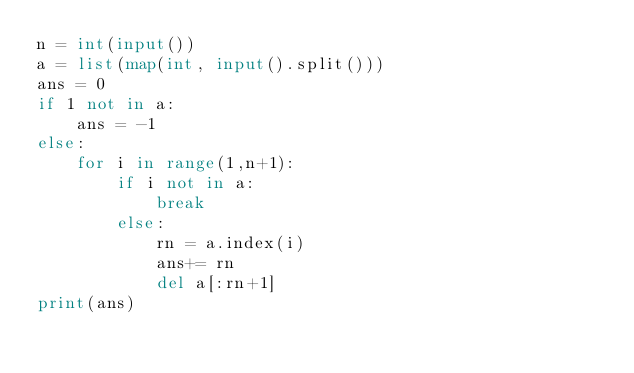<code> <loc_0><loc_0><loc_500><loc_500><_Python_>n = int(input())
a = list(map(int, input().split()))
ans = 0
if 1 not in a:
    ans = -1
else:
    for i in range(1,n+1):
        if i not in a:
            break
        else:
            rn = a.index(i)
            ans+= rn
            del a[:rn+1]
print(ans)</code> 